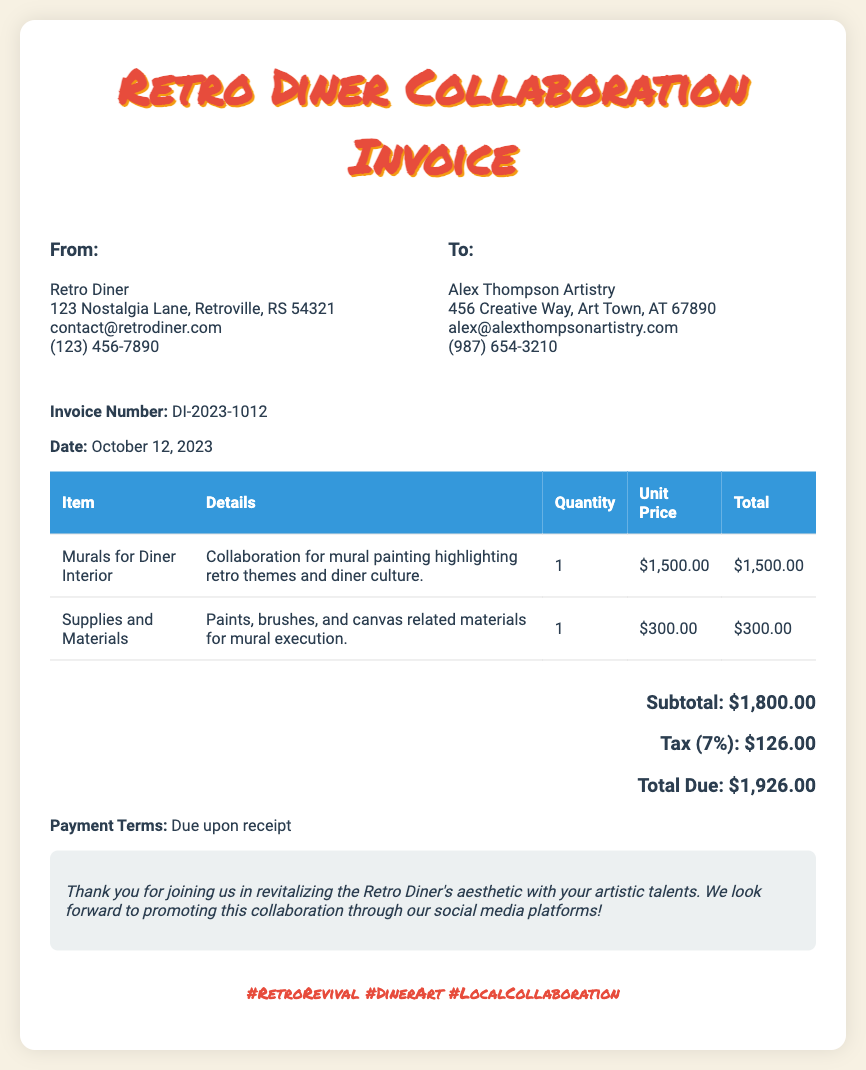What is the invoice number? The invoice number is explicitly stated in the document as a unique identifier for the transaction.
Answer: DI-2023-1012 What is the total due amount? The total due amount is clearly mentioned at the end of the invoice as the final amount owed for the services rendered.
Answer: $1,926.00 Who is the artist collaborating with Retro Diner? The name of the artist is provided in the "To" section of the invoice, detailing the recipient of the invoice.
Answer: Alex Thompson Artistry What is the subtotal before tax? The subtotal is calculated by summing the costs of the items before tax is applied, and this is stated explicitly in the invoice.
Answer: $1,800.00 What does the collaboration focus on? The details in the invoice specify that the collaboration is centered around enhancing the diner with artistic themes related to its culture.
Answer: Mural painting highlighting retro themes and diner culture What is the tax rate applied to the invoice? The tax rate used for the calculation is noted directly within the total section of the document.
Answer: 7% What is the payment term? The payment terms are defined clearly in the document, providing guidance on when payment is expected.
Answer: Due upon receipt What materials were included in the supplies? The document lists specific items related to the materials used for the execution of the mural, which are mentioned in detail.
Answer: Paints, brushes, and canvas related materials 